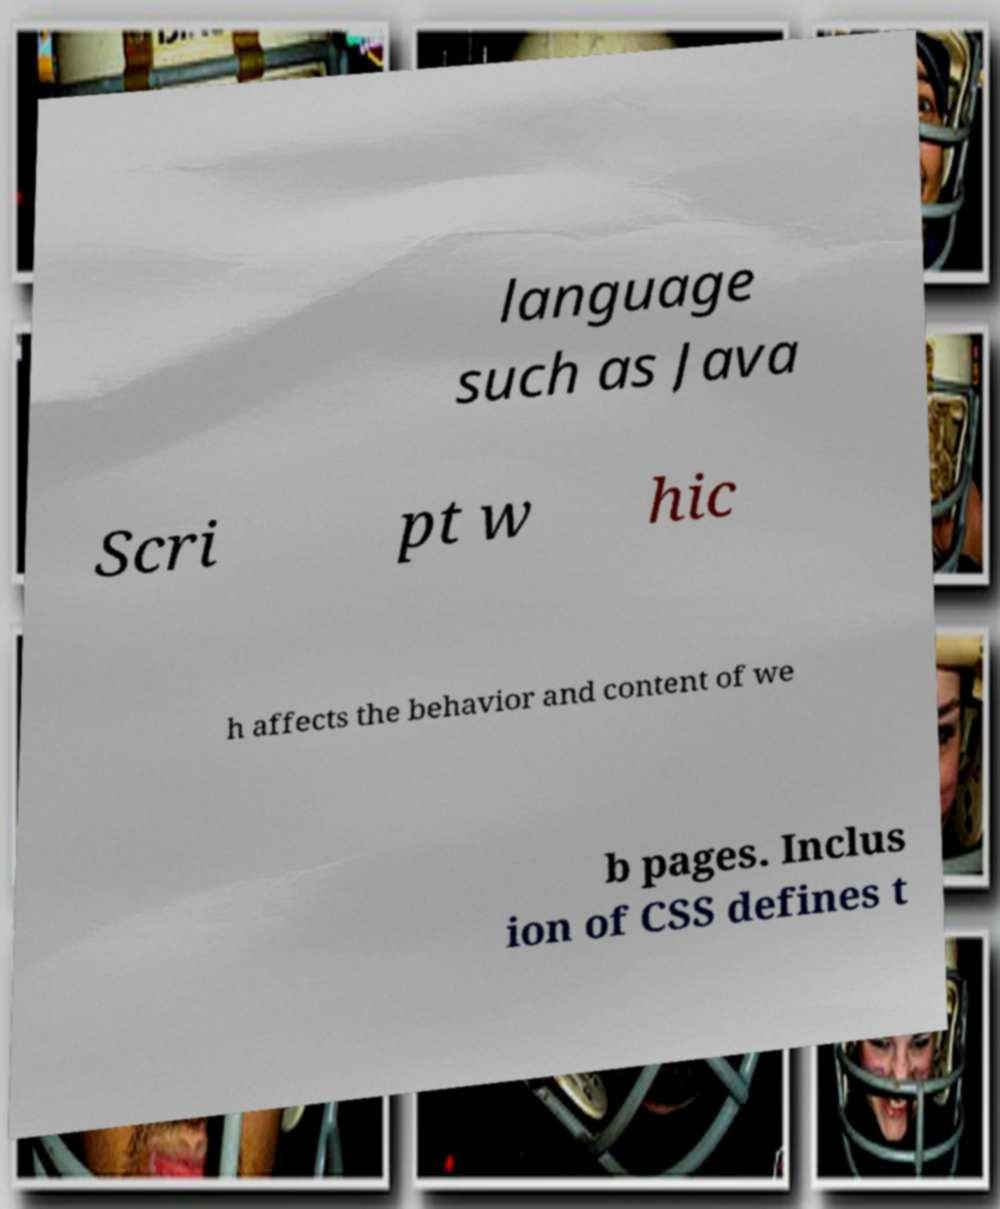Could you extract and type out the text from this image? language such as Java Scri pt w hic h affects the behavior and content of we b pages. Inclus ion of CSS defines t 